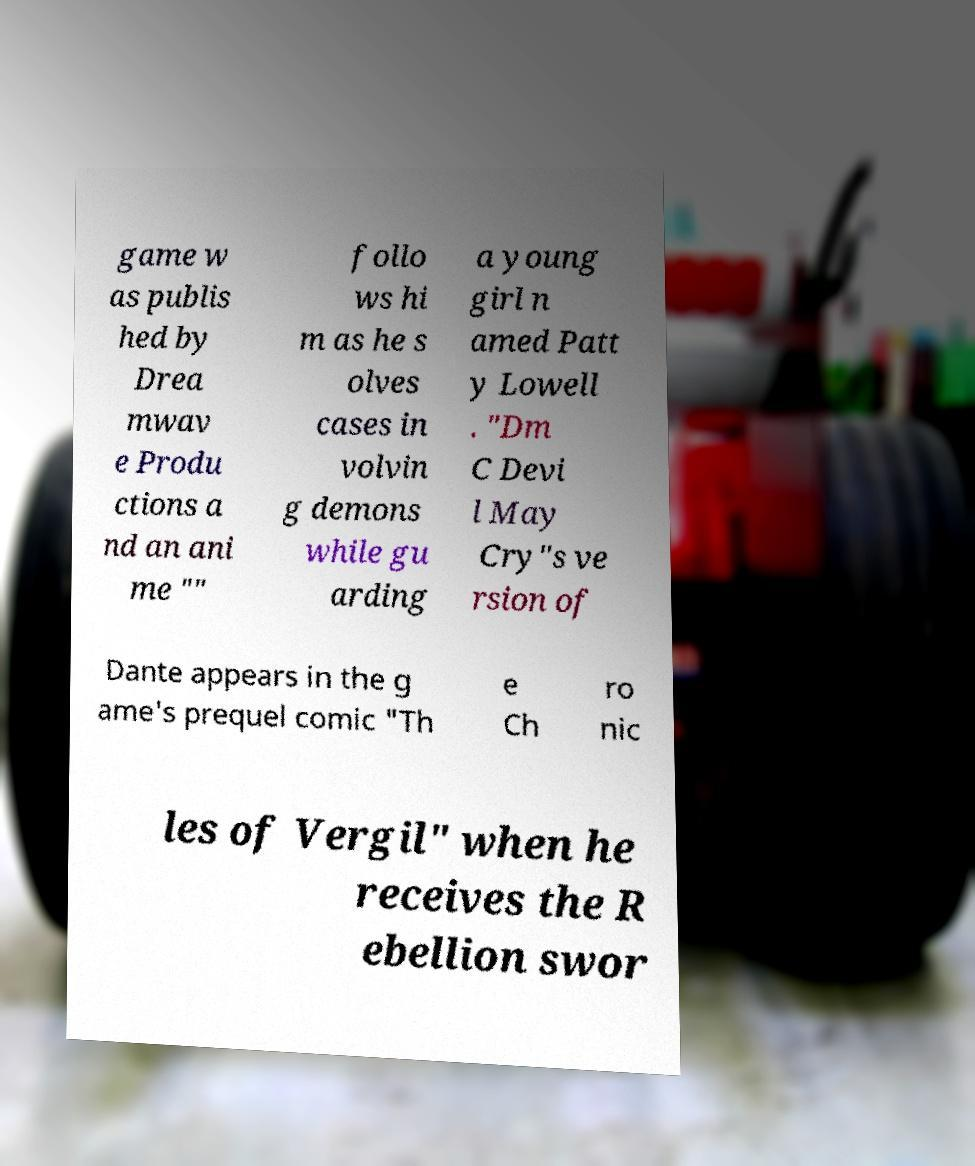For documentation purposes, I need the text within this image transcribed. Could you provide that? game w as publis hed by Drea mwav e Produ ctions a nd an ani me "" follo ws hi m as he s olves cases in volvin g demons while gu arding a young girl n amed Patt y Lowell . "Dm C Devi l May Cry"s ve rsion of Dante appears in the g ame's prequel comic "Th e Ch ro nic les of Vergil" when he receives the R ebellion swor 